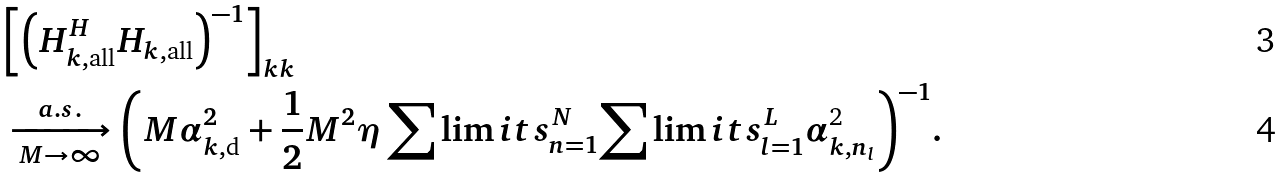<formula> <loc_0><loc_0><loc_500><loc_500>& { \left [ { { { \left ( { { H } _ { k , { \text {all} } } ^ { H } { { H } _ { k , { \text {all} } } } } \right ) } ^ { - 1 } } } \right ] _ { k k } } \\ & \xrightarrow [ { M \to \infty } ] { a . s . } { \left ( { M \alpha _ { k , { \text {d} } } ^ { 2 } + \frac { 1 } { 2 } { M ^ { 2 } } \eta \sum \lim i t s _ { n = 1 } ^ { N } { \sum \lim i t s _ { l = 1 } ^ { L } { \alpha _ { k , { n _ { l } } } ^ { \text {2} } } } } \right ) ^ { - 1 } } .</formula> 